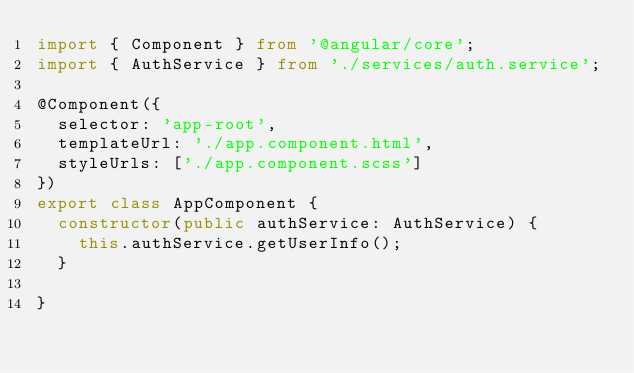Convert code to text. <code><loc_0><loc_0><loc_500><loc_500><_TypeScript_>import { Component } from '@angular/core';
import { AuthService } from './services/auth.service';

@Component({
  selector: 'app-root',
  templateUrl: './app.component.html',
  styleUrls: ['./app.component.scss']
})
export class AppComponent {
  constructor(public authService: AuthService) {
    this.authService.getUserInfo();
  }

}
</code> 